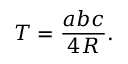Convert formula to latex. <formula><loc_0><loc_0><loc_500><loc_500>T = { \frac { a b c } { 4 R } } .</formula> 